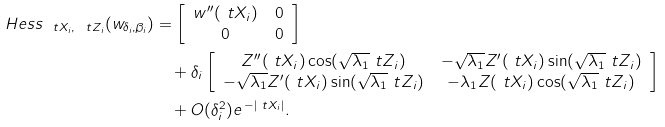Convert formula to latex. <formula><loc_0><loc_0><loc_500><loc_500>H e s s _ { \ t X _ { i } , \ t Z _ { i } } ( w _ { \delta _ { i } , \beta _ { i } } ) & = \left [ \begin{array} { c c } w ^ { \prime \prime } ( \ t X _ { i } ) & 0 \\ 0 & 0 \end{array} \right ] \\ & \quad + \delta _ { i } \left [ \begin{array} { c c } Z ^ { \prime \prime } ( \ t X _ { i } ) \cos ( \sqrt { \lambda _ { 1 } } \ t Z _ { i } ) & - \sqrt { \lambda _ { 1 } } Z ^ { \prime } ( \ t X _ { i } ) \sin ( \sqrt { \lambda _ { 1 } } \ t Z _ { i } ) \\ - \sqrt { \lambda _ { 1 } } Z ^ { \prime } ( \ t X _ { i } ) \sin ( \sqrt { \lambda _ { 1 } } \ t Z _ { i } ) & - \lambda _ { 1 } Z ( \ t X _ { i } ) \cos ( \sqrt { \lambda _ { 1 } } \ t Z _ { i } ) \end{array} \right ] \\ & \quad + O ( \delta _ { i } ^ { 2 } ) e ^ { \, - | \ t X _ { i } | } .</formula> 